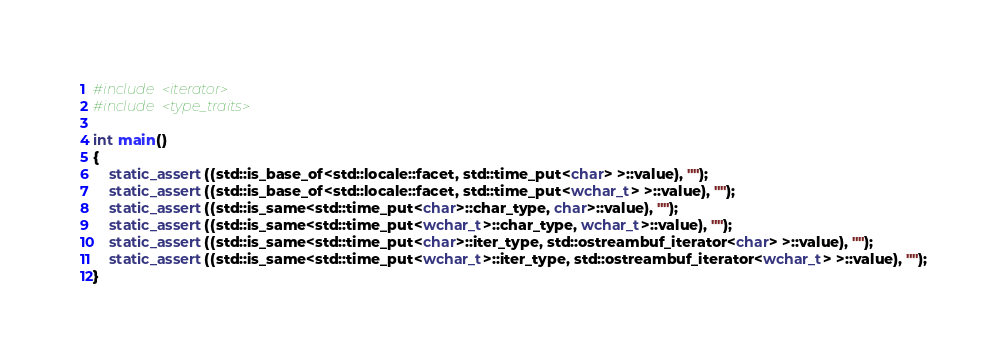<code> <loc_0><loc_0><loc_500><loc_500><_C++_>#include <iterator>
#include <type_traits>

int main()
{
    static_assert((std::is_base_of<std::locale::facet, std::time_put<char> >::value), "");
    static_assert((std::is_base_of<std::locale::facet, std::time_put<wchar_t> >::value), "");
    static_assert((std::is_same<std::time_put<char>::char_type, char>::value), "");
    static_assert((std::is_same<std::time_put<wchar_t>::char_type, wchar_t>::value), "");
    static_assert((std::is_same<std::time_put<char>::iter_type, std::ostreambuf_iterator<char> >::value), "");
    static_assert((std::is_same<std::time_put<wchar_t>::iter_type, std::ostreambuf_iterator<wchar_t> >::value), "");
}
</code> 